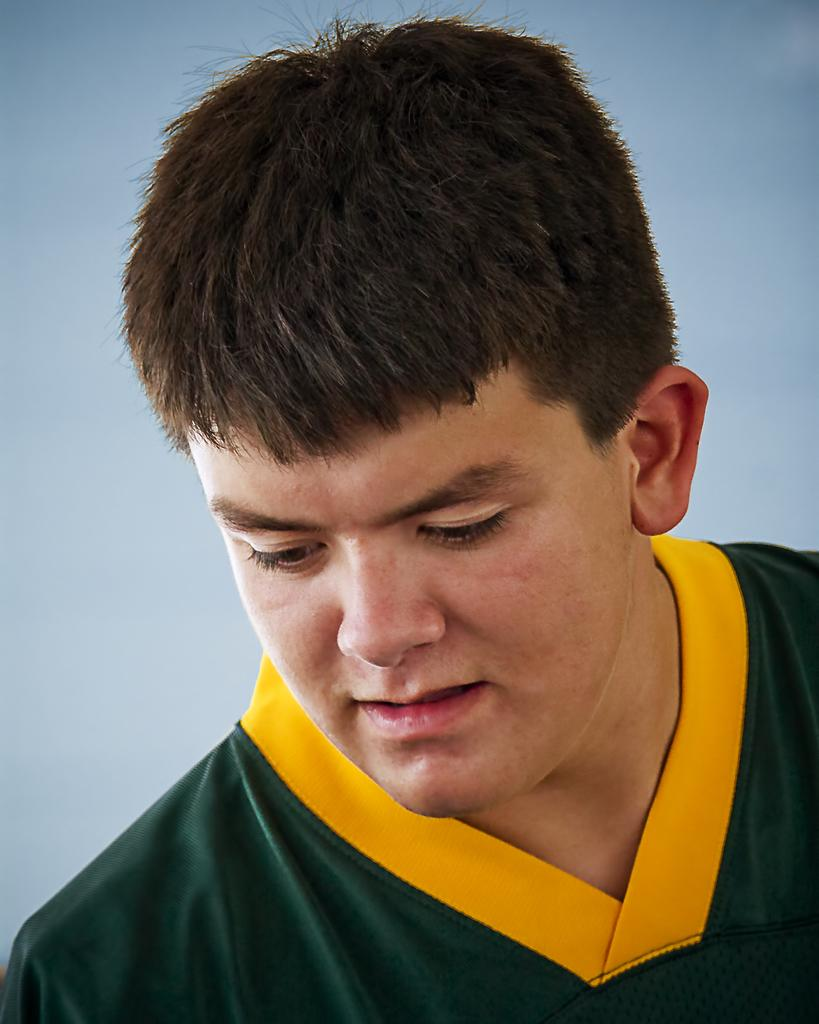What is the main subject of the picture? The main subject of the picture is a man. Can you describe the man's clothing in the picture? The man is wearing a green and yellow color t-shirt. What type of watch is the man wearing in the picture? There is no watch visible in the picture; the man is only wearing a green and yellow color t-shirt. 